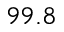<formula> <loc_0><loc_0><loc_500><loc_500>9 9 . 8</formula> 